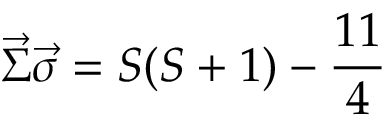Convert formula to latex. <formula><loc_0><loc_0><loc_500><loc_500>\vec { \Sigma } \vec { \sigma } = S ( S + 1 ) - \frac { 1 1 } { 4 }</formula> 